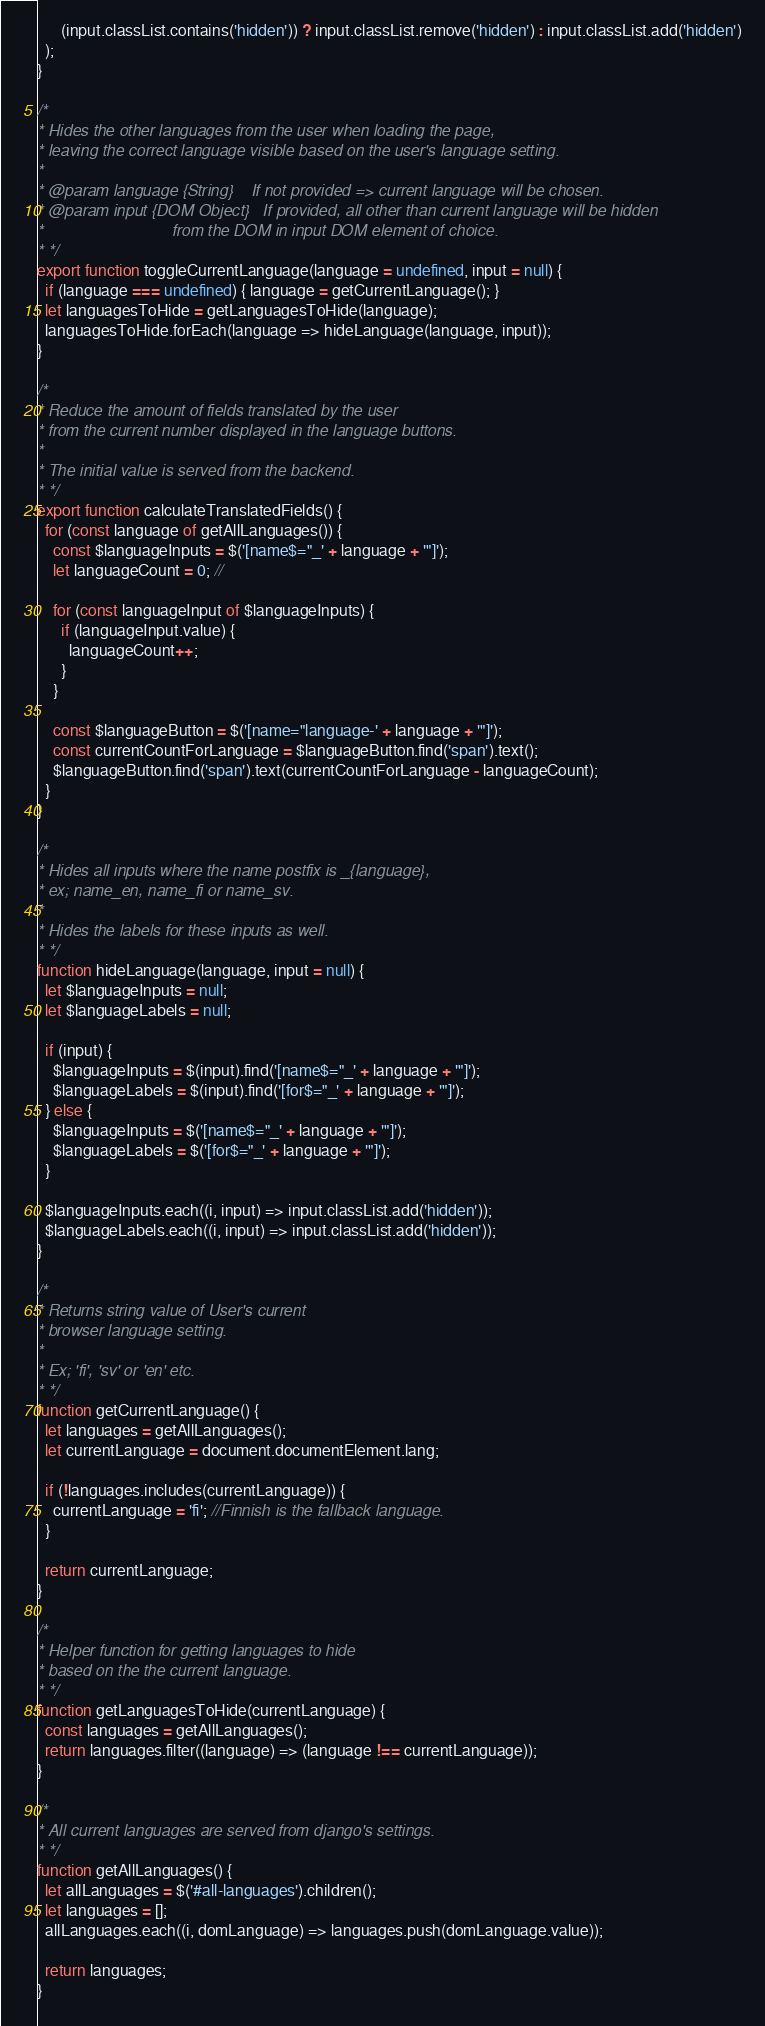<code> <loc_0><loc_0><loc_500><loc_500><_JavaScript_>      (input.classList.contains('hidden')) ? input.classList.remove('hidden') : input.classList.add('hidden')
  );
}

/*
* Hides the other languages from the user when loading the page,
* leaving the correct language visible based on the user's language setting.
*
* @param language {String}    If not provided => current language will be chosen.
* @param input {DOM Object}   If provided, all other than current language will be hidden
*                             from the DOM in input DOM element of choice.
* */
export function toggleCurrentLanguage(language = undefined, input = null) {
  if (language === undefined) { language = getCurrentLanguage(); }
  let languagesToHide = getLanguagesToHide(language);
  languagesToHide.forEach(language => hideLanguage(language, input));
}

/*
* Reduce the amount of fields translated by the user
* from the current number displayed in the language buttons.
*
* The initial value is served from the backend.
* */
export function calculateTranslatedFields() {
  for (const language of getAllLanguages()) {
    const $languageInputs = $('[name$="_' + language + '"]');
    let languageCount = 0; //

    for (const languageInput of $languageInputs) {
      if (languageInput.value) {
        languageCount++;
      }
    }

    const $languageButton = $('[name="language-' + language + '"]');
    const currentCountForLanguage = $languageButton.find('span').text();
    $languageButton.find('span').text(currentCountForLanguage - languageCount);
  }
}

/*
* Hides all inputs where the name postfix is _{language},
* ex; name_en, name_fi or name_sv.
*
* Hides the labels for these inputs as well.
* */
function hideLanguage(language, input = null) {
  let $languageInputs = null;
  let $languageLabels = null;

  if (input) {
    $languageInputs = $(input).find('[name$="_' + language + '"]');
    $languageLabels = $(input).find('[for$="_' + language + '"]');
  } else {
    $languageInputs = $('[name$="_' + language + '"]');
    $languageLabels = $('[for$="_' + language + '"]');
  }

  $languageInputs.each((i, input) => input.classList.add('hidden'));
  $languageLabels.each((i, input) => input.classList.add('hidden'));
}

/*
* Returns string value of User's current
* browser language setting.
*
* Ex; 'fi', 'sv' or 'en' etc.
* */
function getCurrentLanguage() {
  let languages = getAllLanguages();
  let currentLanguage = document.documentElement.lang;

  if (!languages.includes(currentLanguage)) {
    currentLanguage = 'fi'; //Finnish is the fallback language.
  }

  return currentLanguage;
}

/*
* Helper function for getting languages to hide
* based on the the current language.
* */
function getLanguagesToHide(currentLanguage) {
  const languages = getAllLanguages();
  return languages.filter((language) => (language !== currentLanguage));
}

/*
* All current languages are served from django's settings.
* */
function getAllLanguages() {
  let allLanguages = $('#all-languages').children();
  let languages = [];
  allLanguages.each((i, domLanguage) => languages.push(domLanguage.value));

  return languages;
}
</code> 